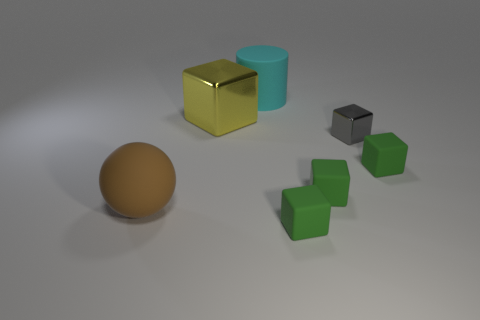How many green blocks must be subtracted to get 2 green blocks? 1 Subtract all yellow balls. How many green cubes are left? 3 Subtract all green cubes. How many cubes are left? 2 Subtract 3 blocks. How many blocks are left? 2 Add 1 purple spheres. How many objects exist? 8 Subtract all yellow cubes. How many cubes are left? 4 Subtract all brown cubes. Subtract all yellow spheres. How many cubes are left? 5 Add 4 large yellow metallic things. How many large yellow metallic things exist? 5 Subtract 0 green spheres. How many objects are left? 7 Subtract all blocks. How many objects are left? 2 